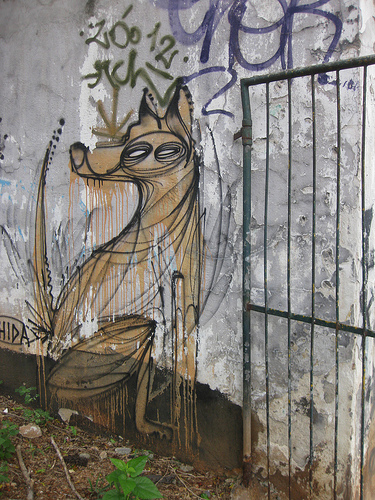<image>
Is there a dog next to the wall? No. The dog is not positioned next to the wall. They are located in different areas of the scene. 